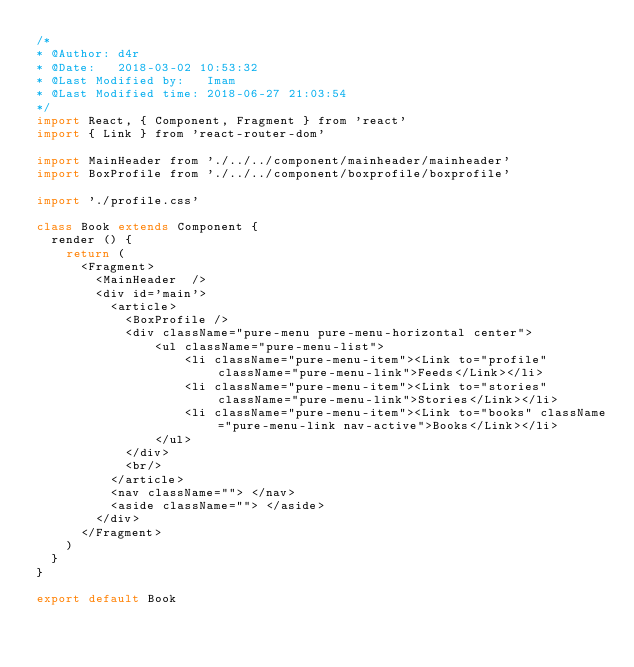<code> <loc_0><loc_0><loc_500><loc_500><_JavaScript_>/*
* @Author: d4r
* @Date:   2018-03-02 10:53:32
* @Last Modified by:   Imam
* @Last Modified time: 2018-06-27 21:03:54
*/
import React, { Component, Fragment } from 'react'
import { Link } from 'react-router-dom'

import MainHeader from './../../component/mainheader/mainheader'
import BoxProfile from './../../component/boxprofile/boxprofile'

import './profile.css'

class Book extends Component {
	render () {
		return (
			<Fragment>
				<MainHeader  />
				<div id='main'>
					<article>
						<BoxProfile />
						<div className="pure-menu pure-menu-horizontal center">
						    <ul className="pure-menu-list">
						        <li className="pure-menu-item"><Link to="profile" className="pure-menu-link">Feeds</Link></li>
						        <li className="pure-menu-item"><Link to="stories" className="pure-menu-link">Stories</Link></li>
						        <li className="pure-menu-item"><Link to="books" className="pure-menu-link nav-active">Books</Link></li>
						    </ul>
						</div>
						<br/>
					</article>
					<nav className=""> </nav>
					<aside className=""> </aside>
				</div>
			</Fragment>
		)
	}
}

export default Book</code> 